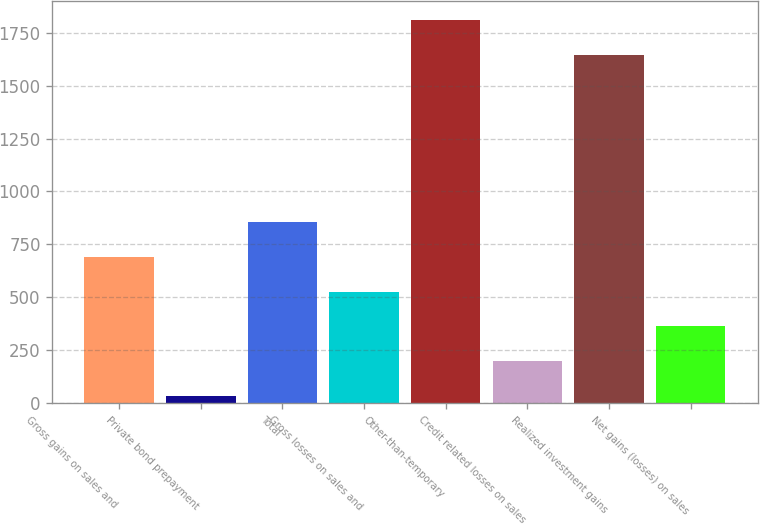<chart> <loc_0><loc_0><loc_500><loc_500><bar_chart><fcel>Gross gains on sales and<fcel>Private bond prepayment<fcel>Total<fcel>Gross losses on sales and<fcel>Other-than-temporary<fcel>Credit related losses on sales<fcel>Realized investment gains<fcel>Net gains (losses) on sales<nl><fcel>691.4<fcel>33<fcel>856<fcel>526.8<fcel>1810.6<fcel>197.6<fcel>1646<fcel>362.2<nl></chart> 